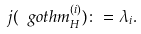<formula> <loc_0><loc_0><loc_500><loc_500>j ( { \ g o t h m } _ { H } ^ { ( i ) } ) \colon = \lambda _ { i } .</formula> 